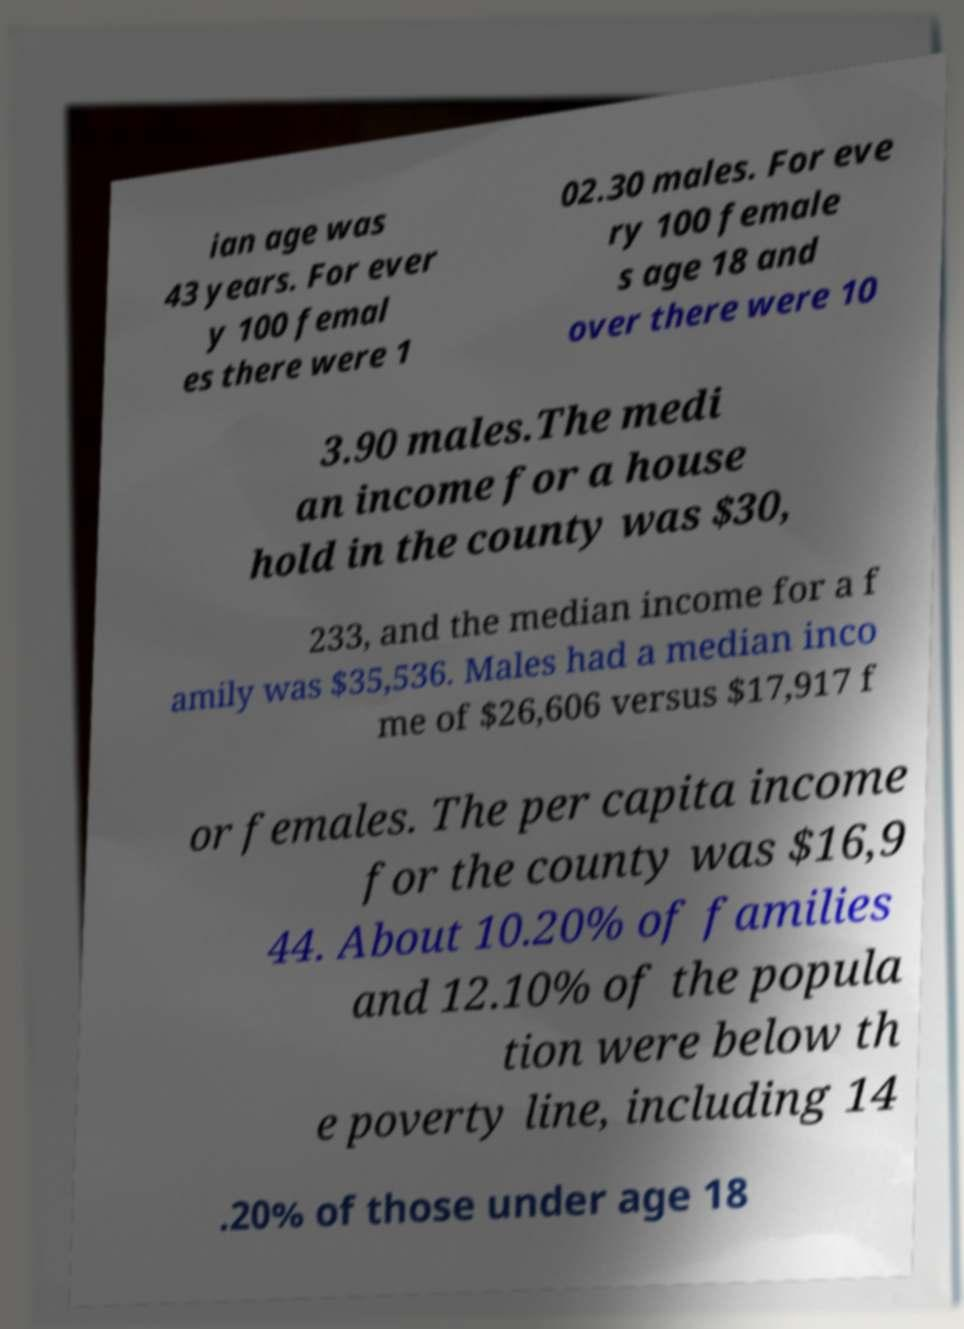Please identify and transcribe the text found in this image. ian age was 43 years. For ever y 100 femal es there were 1 02.30 males. For eve ry 100 female s age 18 and over there were 10 3.90 males.The medi an income for a house hold in the county was $30, 233, and the median income for a f amily was $35,536. Males had a median inco me of $26,606 versus $17,917 f or females. The per capita income for the county was $16,9 44. About 10.20% of families and 12.10% of the popula tion were below th e poverty line, including 14 .20% of those under age 18 